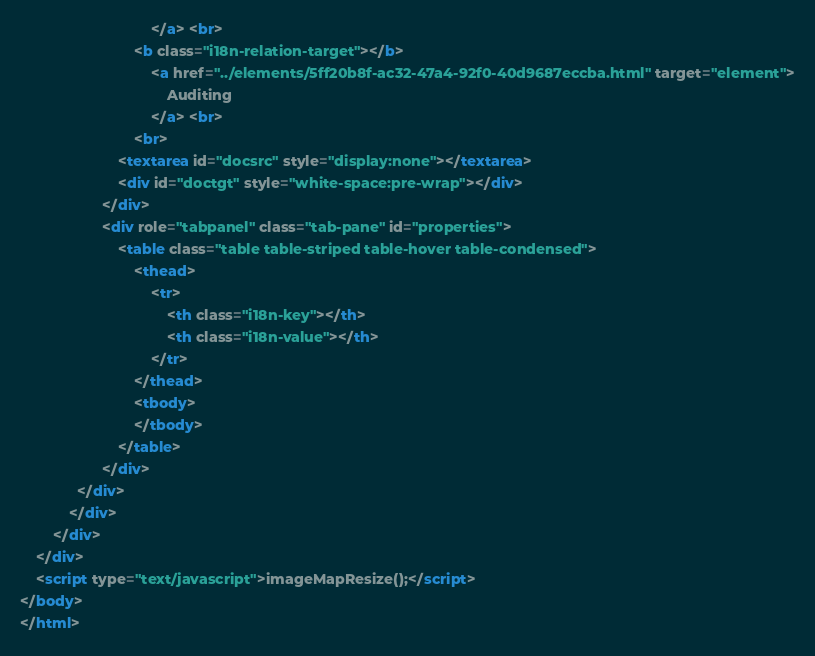Convert code to text. <code><loc_0><loc_0><loc_500><loc_500><_HTML_>								</a> <br>
							<b class="i18n-relation-target"></b>
								<a href="../elements/5ff20b8f-ac32-47a4-92f0-40d9687eccba.html" target="element">
									Auditing
								</a> <br>
							<br>
						<textarea id="docsrc" style="display:none"></textarea>
						<div id="doctgt" style="white-space:pre-wrap"></div>
					</div>
					<div role="tabpanel" class="tab-pane" id="properties">
						<table class="table table-striped table-hover table-condensed">
							<thead>
								<tr>
									<th class="i18n-key"></th>
									<th class="i18n-value"></th>
								</tr>
							</thead>
							<tbody>
							</tbody>
						</table>
					</div>
			  </div>
			</div>
		</div>
	</div>
	<script type="text/javascript">imageMapResize();</script>
</body>
</html></code> 